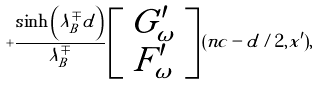<formula> <loc_0><loc_0><loc_500><loc_500>+ \frac { \sinh \left ( \lambda _ { B } ^ { \mp } d \right ) } { \lambda _ { B } ^ { \mp } } \left [ \begin{array} { c } G _ { \omega } ^ { \prime } \\ F _ { \omega } ^ { \prime } \end{array} \right ] ( n c - d / 2 , x ^ { \prime } ) ,</formula> 